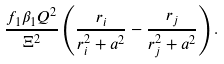Convert formula to latex. <formula><loc_0><loc_0><loc_500><loc_500>\frac { f _ { 1 } \beta _ { 1 } Q ^ { 2 } } { \Xi ^ { 2 } } \left ( \frac { r _ { i } } { r ^ { 2 } _ { i } + a ^ { 2 } } - \frac { r _ { j } } { r ^ { 2 } _ { j } + a ^ { 2 } } \right ) .</formula> 